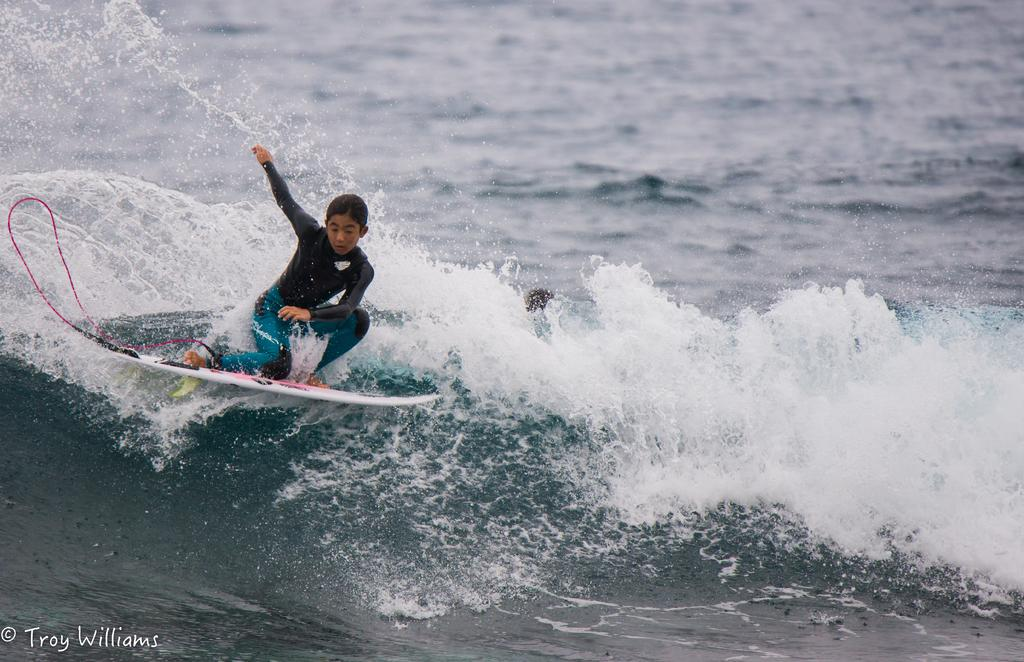Who is the main subject in the image? There is a girl in the image. What is the girl doing in the image? The girl is riding a surfboard. What can be seen in the background of the image? There is an ocean in the background of the image. What type of humor can be seen in the girl's expression while riding the sock in the image? There is no sock present in the image, and the girl is riding a surfboard, not a sock. 